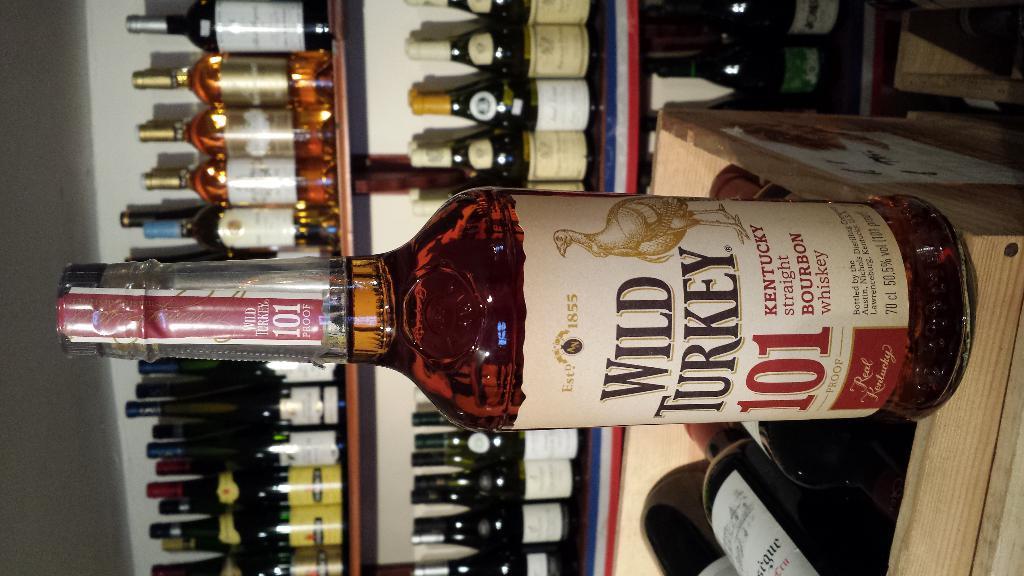Describe this image in one or two sentences. Front this bottle is filled with liquid and there is a sticker on this bottle. This box is filled with bottles. Far this rack is also filled with bottles. 